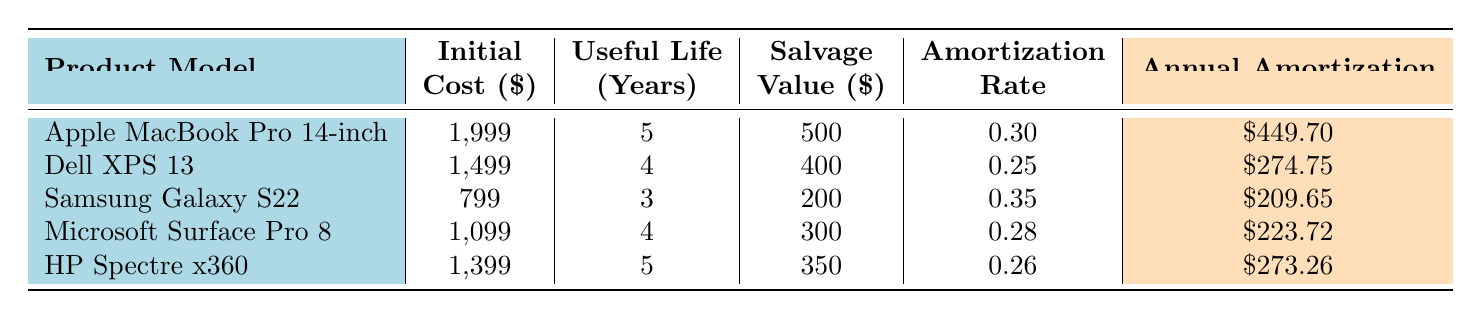What is the initial cost of the Microsoft Surface Pro 8? The table lists the initial cost for each product model. For the Microsoft Surface Pro 8, the initial cost is directly stated as 1,099 dollars.
Answer: 1,099 Which product has the highest annual amortization rate? The annual amortization rates are listed for each product. Comparing them, the Samsung Galaxy S22 has the highest rate at 0.35.
Answer: Samsung Galaxy S22 What is the average annual amortization for all products combined? First, we identify the annual amortization amounts: 449.70, 274.75, 209.65, 223.72, and 273.26. Summing these gives 1,530.08. Dividing by the number of products (5) gives an average of 1,530.08 / 5 = 306.02.
Answer: 306.02 Is the salvage value of the HP Spectre x360 higher than that of the Dell XPS 13? The salvage value of HP Spectre x360 is 350 dollars and for Dell XPS 13, it is 400 dollars. Since 350 is less than 400, the statement is false.
Answer: No If you add the initial costs of the Apple MacBook Pro and the Dell XPS 13, how much do you get? The initial cost of the Apple MacBook Pro is 1,999 and of the Dell XPS 13 is 1,499. Adding these gives 1,999 + 1,499 = 3,498.
Answer: 3,498 Which product has the longest useful life? The table indicates the useful life in years for each product. The Apple MacBook Pro 14-inch has the longest useful life at 5 years.
Answer: Apple MacBook Pro 14-inch Do all products have a salvage value greater than 200 dollars? Looking at the salvage values, Apple MacBook Pro (500), Dell XPS 13 (400), Samsung Galaxy S22 (200), Microsoft Surface Pro 8 (300), and HP Spectre x360 (350) are all greater than or equal to 200 dollars. Thus, the statement is true.
Answer: Yes What is the total initial cost of all the products listed? The total initial cost is determined by adding the initial costs together: 1,999 + 1,499 + 799 + 1,099 + 1,399 = 6,794.
Answer: 6,794 Which product has the smallest annual amortization? The annual amortization amounts are 449.70, 274.75, 209.65, 223.72, and 273.26. The smallest among these is 209.65 for the Samsung Galaxy S22.
Answer: Samsung Galaxy S22 